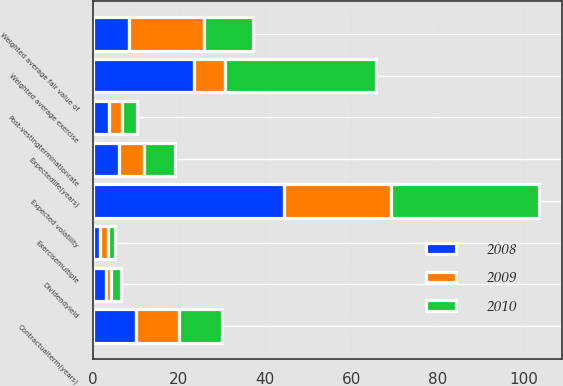Convert chart to OTSL. <chart><loc_0><loc_0><loc_500><loc_500><stacked_bar_chart><ecel><fcel>Dividendyield<fcel>Expected volatility<fcel>Exercisemultiple<fcel>Post-vestingterminationrate<fcel>Contractualterm(years)<fcel>Expectedlife(years)<fcel>Weighted average exercise<fcel>Weighted average fair value of<nl><fcel>2010<fcel>2.11<fcel>34.41<fcel>1.75<fcel>3.64<fcel>10<fcel>7<fcel>35.06<fcel>11.29<nl><fcel>2008<fcel>3.15<fcel>44.39<fcel>1.76<fcel>3.7<fcel>10<fcel>6<fcel>23.61<fcel>8.37<nl><fcel>2009<fcel>1.21<fcel>24.85<fcel>1.73<fcel>3.05<fcel>10<fcel>6<fcel>7<fcel>17.51<nl></chart> 